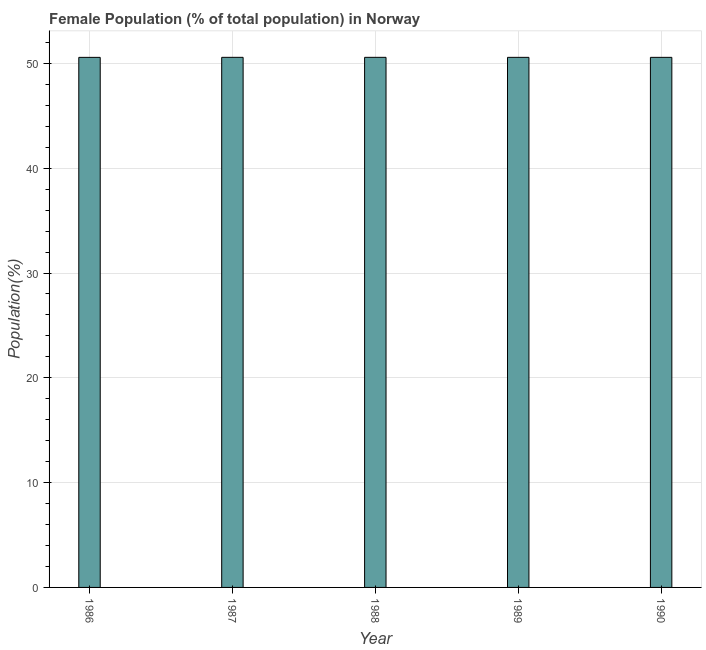What is the title of the graph?
Ensure brevity in your answer.  Female Population (% of total population) in Norway. What is the label or title of the Y-axis?
Provide a succinct answer. Population(%). What is the female population in 1986?
Your response must be concise. 50.58. Across all years, what is the maximum female population?
Offer a very short reply. 50.58. Across all years, what is the minimum female population?
Ensure brevity in your answer.  50.58. What is the sum of the female population?
Give a very brief answer. 252.89. What is the difference between the female population in 1986 and 1987?
Offer a terse response. -0. What is the average female population per year?
Provide a short and direct response. 50.58. What is the median female population?
Your response must be concise. 50.58. What is the ratio of the female population in 1987 to that in 1990?
Provide a short and direct response. 1. Is the female population in 1986 less than that in 1990?
Ensure brevity in your answer.  Yes. Is the difference between the female population in 1987 and 1988 greater than the difference between any two years?
Your answer should be very brief. No. What is the difference between the highest and the second highest female population?
Keep it short and to the point. 0. What is the difference between the highest and the lowest female population?
Give a very brief answer. 0. What is the Population(%) of 1986?
Offer a very short reply. 50.58. What is the Population(%) of 1987?
Ensure brevity in your answer.  50.58. What is the Population(%) of 1988?
Offer a very short reply. 50.58. What is the Population(%) in 1989?
Offer a very short reply. 50.58. What is the Population(%) of 1990?
Ensure brevity in your answer.  50.58. What is the difference between the Population(%) in 1986 and 1987?
Your answer should be compact. -0. What is the difference between the Population(%) in 1986 and 1988?
Provide a succinct answer. -0. What is the difference between the Population(%) in 1986 and 1989?
Give a very brief answer. -0. What is the difference between the Population(%) in 1986 and 1990?
Keep it short and to the point. -0. What is the difference between the Population(%) in 1987 and 1988?
Your answer should be very brief. 0. What is the difference between the Population(%) in 1987 and 1989?
Your answer should be very brief. 0. What is the difference between the Population(%) in 1987 and 1990?
Provide a succinct answer. 0. What is the difference between the Population(%) in 1988 and 1989?
Ensure brevity in your answer.  0. What is the difference between the Population(%) in 1988 and 1990?
Your answer should be very brief. 0. What is the difference between the Population(%) in 1989 and 1990?
Offer a terse response. 0. What is the ratio of the Population(%) in 1986 to that in 1987?
Offer a terse response. 1. What is the ratio of the Population(%) in 1986 to that in 1988?
Your answer should be compact. 1. What is the ratio of the Population(%) in 1986 to that in 1989?
Give a very brief answer. 1. What is the ratio of the Population(%) in 1986 to that in 1990?
Your answer should be very brief. 1. What is the ratio of the Population(%) in 1987 to that in 1988?
Ensure brevity in your answer.  1. What is the ratio of the Population(%) in 1987 to that in 1989?
Offer a very short reply. 1. What is the ratio of the Population(%) in 1987 to that in 1990?
Ensure brevity in your answer.  1. What is the ratio of the Population(%) in 1989 to that in 1990?
Your answer should be compact. 1. 